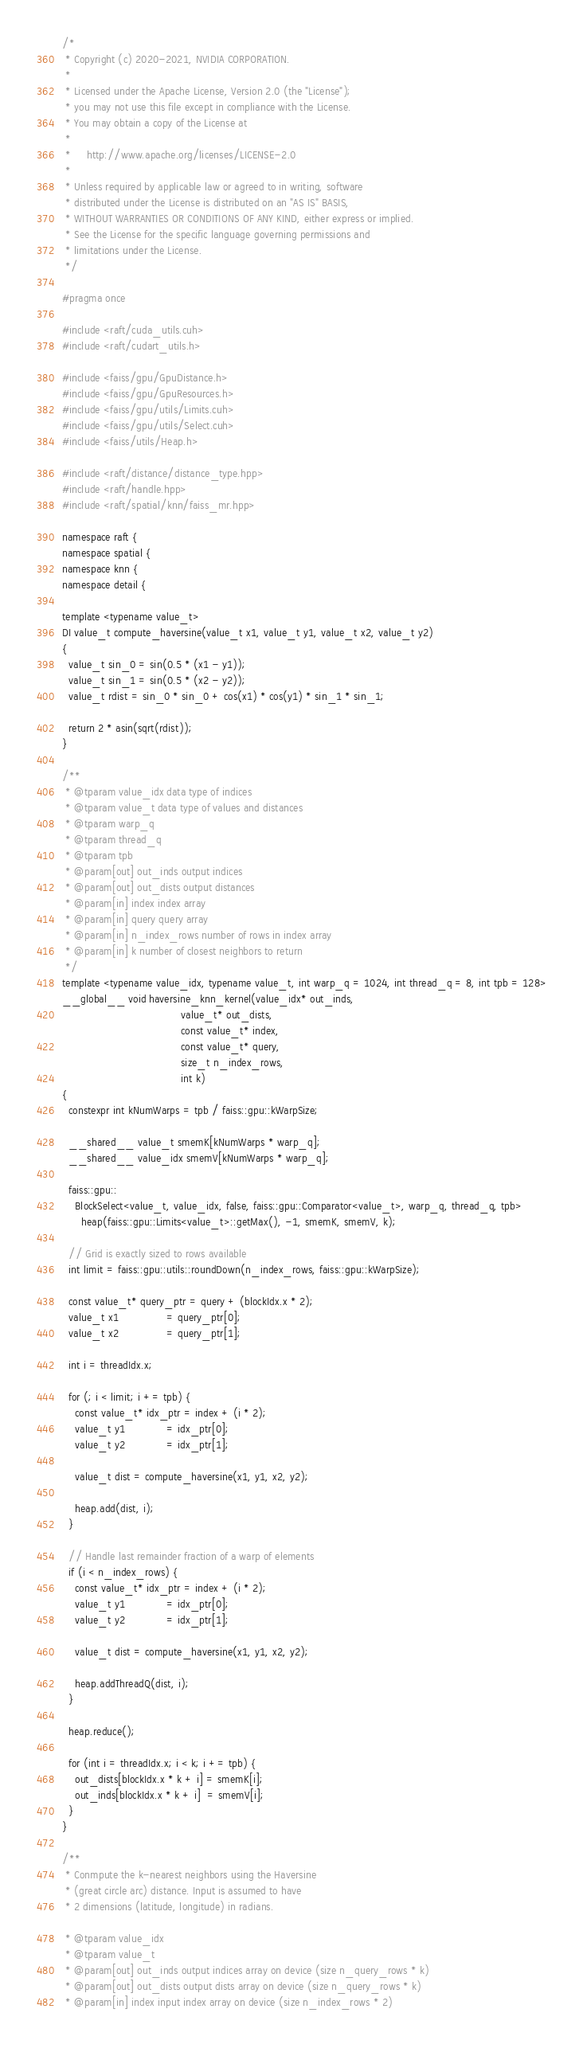<code> <loc_0><loc_0><loc_500><loc_500><_Cuda_>/*
 * Copyright (c) 2020-2021, NVIDIA CORPORATION.
 *
 * Licensed under the Apache License, Version 2.0 (the "License");
 * you may not use this file except in compliance with the License.
 * You may obtain a copy of the License at
 *
 *     http://www.apache.org/licenses/LICENSE-2.0
 *
 * Unless required by applicable law or agreed to in writing, software
 * distributed under the License is distributed on an "AS IS" BASIS,
 * WITHOUT WARRANTIES OR CONDITIONS OF ANY KIND, either express or implied.
 * See the License for the specific language governing permissions and
 * limitations under the License.
 */

#pragma once

#include <raft/cuda_utils.cuh>
#include <raft/cudart_utils.h>

#include <faiss/gpu/GpuDistance.h>
#include <faiss/gpu/GpuResources.h>
#include <faiss/gpu/utils/Limits.cuh>
#include <faiss/gpu/utils/Select.cuh>
#include <faiss/utils/Heap.h>

#include <raft/distance/distance_type.hpp>
#include <raft/handle.hpp>
#include <raft/spatial/knn/faiss_mr.hpp>

namespace raft {
namespace spatial {
namespace knn {
namespace detail {

template <typename value_t>
DI value_t compute_haversine(value_t x1, value_t y1, value_t x2, value_t y2)
{
  value_t sin_0 = sin(0.5 * (x1 - y1));
  value_t sin_1 = sin(0.5 * (x2 - y2));
  value_t rdist = sin_0 * sin_0 + cos(x1) * cos(y1) * sin_1 * sin_1;

  return 2 * asin(sqrt(rdist));
}

/**
 * @tparam value_idx data type of indices
 * @tparam value_t data type of values and distances
 * @tparam warp_q
 * @tparam thread_q
 * @tparam tpb
 * @param[out] out_inds output indices
 * @param[out] out_dists output distances
 * @param[in] index index array
 * @param[in] query query array
 * @param[in] n_index_rows number of rows in index array
 * @param[in] k number of closest neighbors to return
 */
template <typename value_idx, typename value_t, int warp_q = 1024, int thread_q = 8, int tpb = 128>
__global__ void haversine_knn_kernel(value_idx* out_inds,
                                     value_t* out_dists,
                                     const value_t* index,
                                     const value_t* query,
                                     size_t n_index_rows,
                                     int k)
{
  constexpr int kNumWarps = tpb / faiss::gpu::kWarpSize;

  __shared__ value_t smemK[kNumWarps * warp_q];
  __shared__ value_idx smemV[kNumWarps * warp_q];

  faiss::gpu::
    BlockSelect<value_t, value_idx, false, faiss::gpu::Comparator<value_t>, warp_q, thread_q, tpb>
      heap(faiss::gpu::Limits<value_t>::getMax(), -1, smemK, smemV, k);

  // Grid is exactly sized to rows available
  int limit = faiss::gpu::utils::roundDown(n_index_rows, faiss::gpu::kWarpSize);

  const value_t* query_ptr = query + (blockIdx.x * 2);
  value_t x1               = query_ptr[0];
  value_t x2               = query_ptr[1];

  int i = threadIdx.x;

  for (; i < limit; i += tpb) {
    const value_t* idx_ptr = index + (i * 2);
    value_t y1             = idx_ptr[0];
    value_t y2             = idx_ptr[1];

    value_t dist = compute_haversine(x1, y1, x2, y2);

    heap.add(dist, i);
  }

  // Handle last remainder fraction of a warp of elements
  if (i < n_index_rows) {
    const value_t* idx_ptr = index + (i * 2);
    value_t y1             = idx_ptr[0];
    value_t y2             = idx_ptr[1];

    value_t dist = compute_haversine(x1, y1, x2, y2);

    heap.addThreadQ(dist, i);
  }

  heap.reduce();

  for (int i = threadIdx.x; i < k; i += tpb) {
    out_dists[blockIdx.x * k + i] = smemK[i];
    out_inds[blockIdx.x * k + i]  = smemV[i];
  }
}

/**
 * Conmpute the k-nearest neighbors using the Haversine
 * (great circle arc) distance. Input is assumed to have
 * 2 dimensions (latitude, longitude) in radians.

 * @tparam value_idx
 * @tparam value_t
 * @param[out] out_inds output indices array on device (size n_query_rows * k)
 * @param[out] out_dists output dists array on device (size n_query_rows * k)
 * @param[in] index input index array on device (size n_index_rows * 2)</code> 